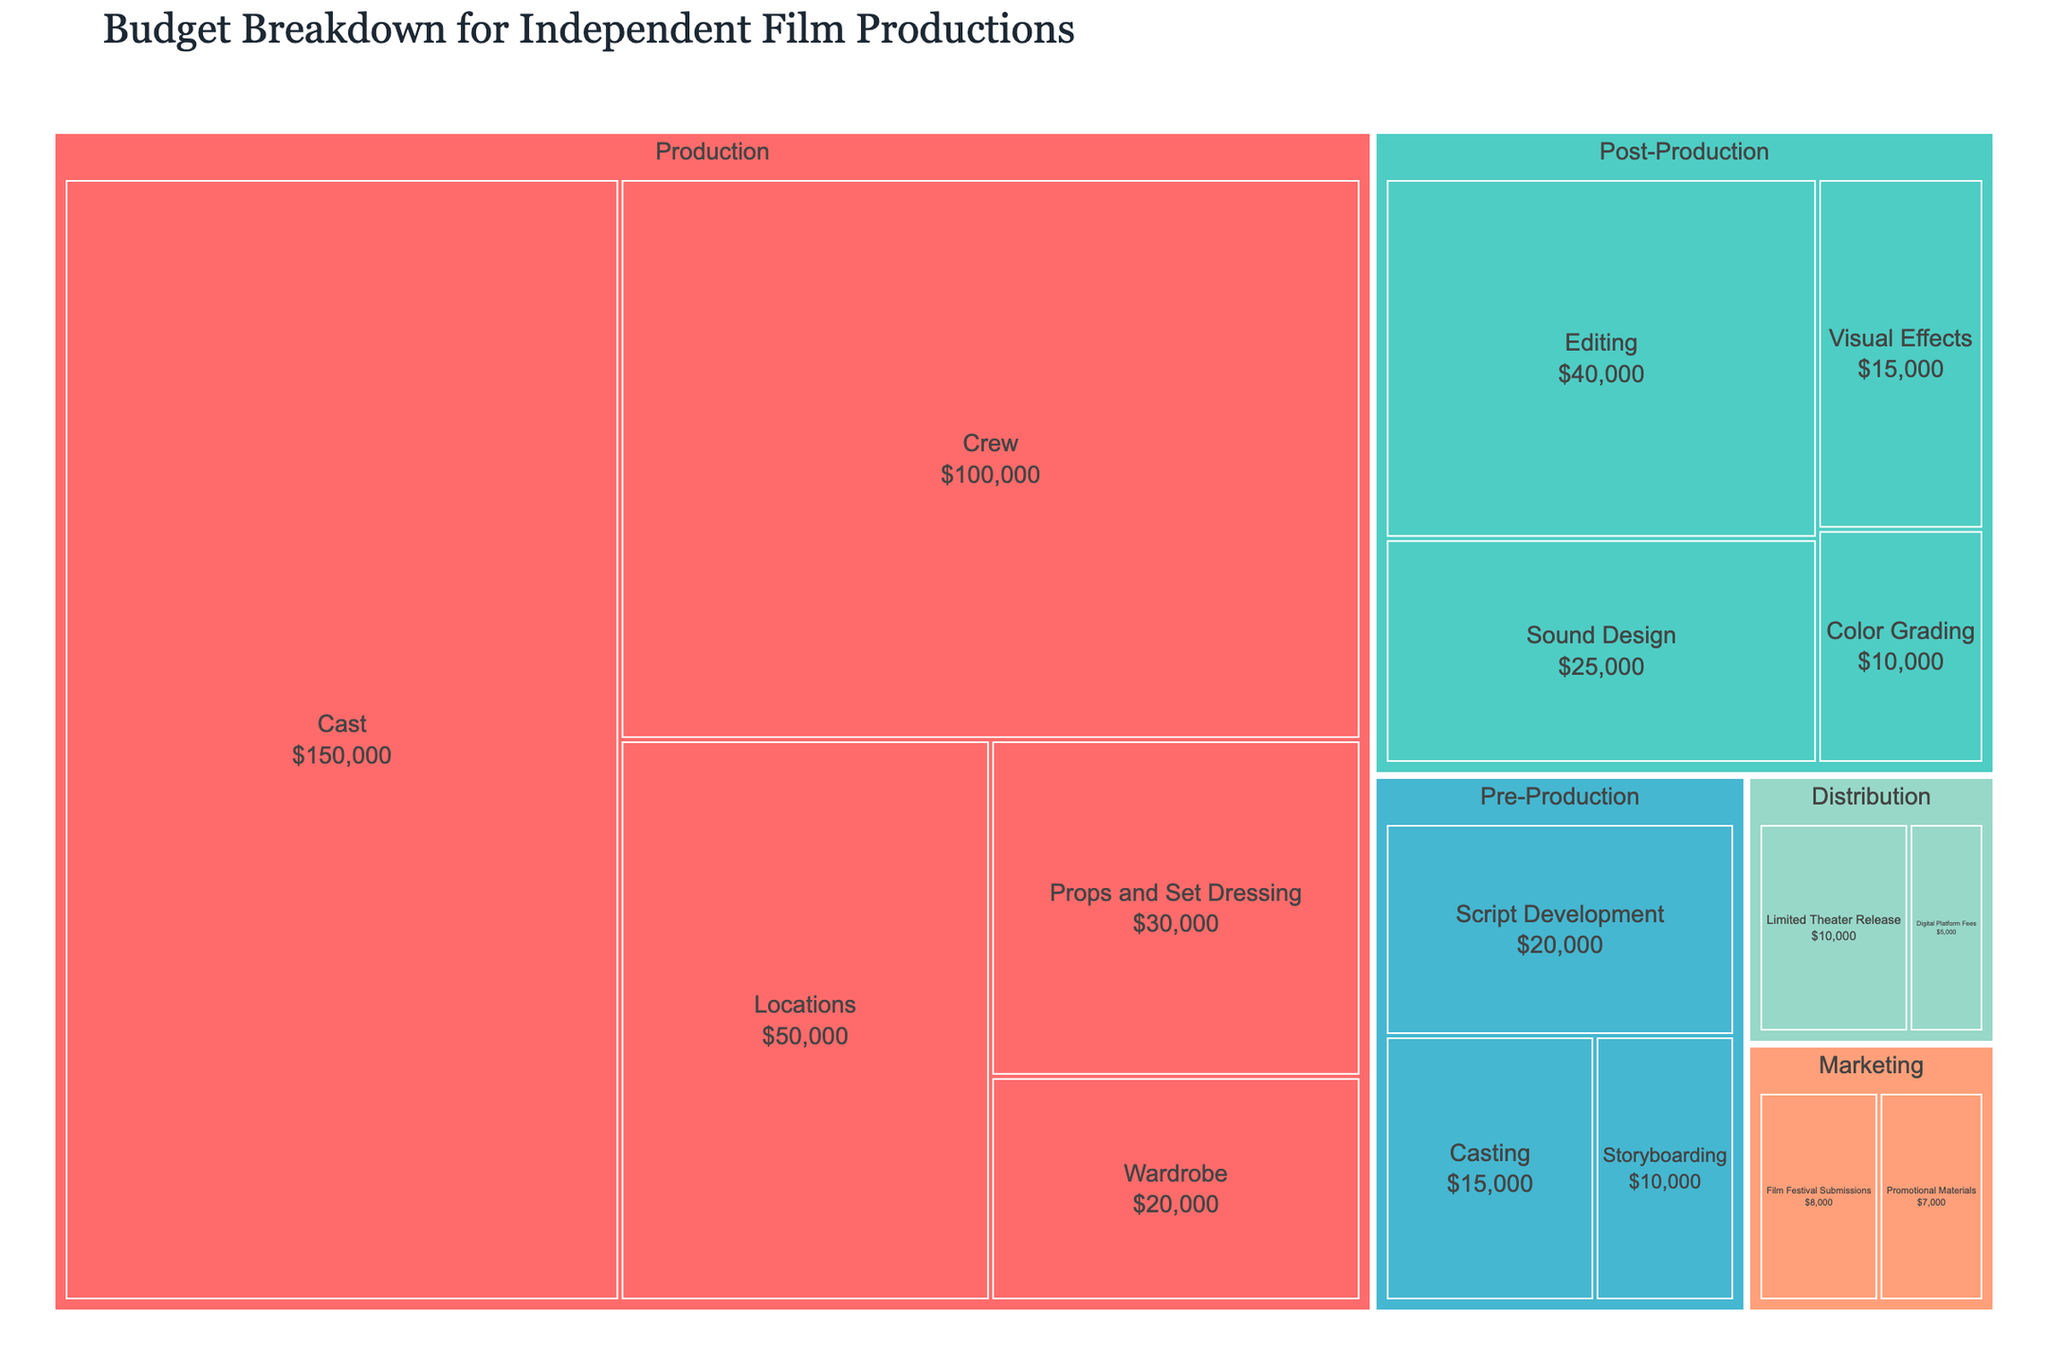What is the highest budget category in the Production department? By observing the Production department in the treemap, the largest rectangle represents the highest budget category. The Cast category is the largest, with a budget of $150,000.
Answer: Cast, $150,000 What is the combined budget for the Post-Production department? The Post-Production department includes Editing ($40,000), Sound Design ($25,000), Visual Effects ($15,000), and Color Grading ($10,000). Adding them together, the combined budget is $40,000 + $25,000 + $15,000 + $10,000 = $90,000.
Answer: $90,000 Which department has the smallest individual budget category? By examining the treemap, the smallest rectangle represents the Film Festival Submissions category in the Marketing department, with a budget of $8,000.
Answer: Marketing, Film Festival Submissions, $8,000 How does the budget for Editing compare to the total budget for Script Development, Casting, and Storyboarding? The budget for Editing is $40,000. The total budget for Script Development, Casting, and Storyboarding is $20,000 (Script Development) + $15,000 (Casting) + $10,000 (Storyboarding) = $45,000. Therefore, Editing ($40,000) is less than the combined budget for Script Development, Casting, and Storyboarding ($45,000).
Answer: Editing is less by $5,000 Which department has a higher budget: Pre-Production or Marketing? The total budget for Pre-Production is $20,000 (Script Development) + $15,000 (Casting) + $10,000 (Storyboarding) = $45,000. The total budget for Marketing is $8,000 (Film Festival Submissions) + $7,000 (Promotional Materials) = $15,000. Comparing both, Pre-Production ($45,000) has a higher budget than Marketing ($15,000).
Answer: Pre-Production What is the total budget allocated to the Distribution department? The Distribution department includes Digital Platform Fees ($5,000) and Limited Theater Release ($10,000). Summing them up, the total budget is $5,000 + $10,000 = $15,000.
Answer: $15,000 Among all the categories, which one has the lowest budget and what is its value? By identifying the smallest rectangle in the treemap, the Film Festival Submissions category in Marketing has the lowest budget at $8,000.
Answer: $8,000 If the budgets for Crew and Locations in the Production department were combined into one category, what would be the total budget for this new category? The Crew budget is $100,000 and the Locations budget is $50,000. Combining them results in $100,000 + $50,000 = $150,000.
Answer: $150,000 What is the difference between the budgets of Props and Set Dressing and Wardrobe in the Production department? The budget for Props and Set Dressing is $30,000 and Wardrobe is $20,000. The difference is $30,000 - $20,000 = $10,000.
Answer: $10,000 Is the budget for Color Grading more or less than half of the budget for Sound Design in Post-Production? The budget for Color Grading is $10,000. Half of the Sound Design budget is $25,000 / 2 = $12,500. Since $10,000 is less than $12,500, the budget for Color Grading is less than half of the Sound Design budget.
Answer: Less 